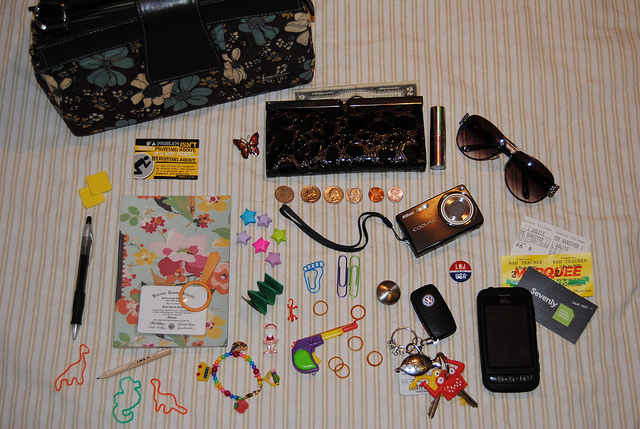Describe three items in this image that look like they have sentimental value. Three items that could hold sentimental value are the beaded bracelet, which might have been handmade or a gift; the charm keychain with multiple colors and shapes, suggesting personalization; and the butterfly hair clip, which could have been chosen for its aesthetic appeal or personal significance. 